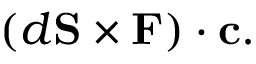<formula> <loc_0><loc_0><loc_500><loc_500>( d S \times F ) \cdot c .</formula> 